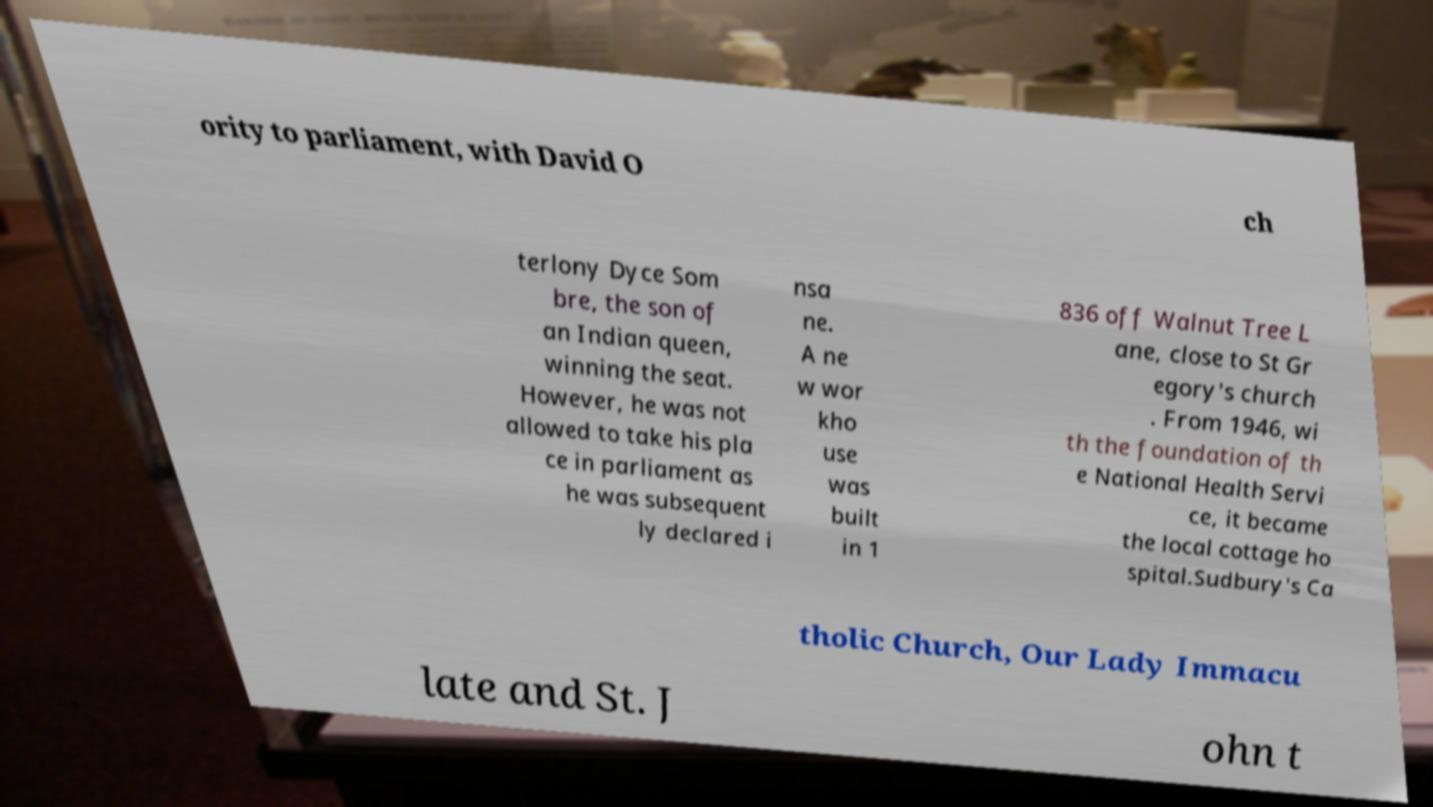Could you assist in decoding the text presented in this image and type it out clearly? ority to parliament, with David O ch terlony Dyce Som bre, the son of an Indian queen, winning the seat. However, he was not allowed to take his pla ce in parliament as he was subsequent ly declared i nsa ne. A ne w wor kho use was built in 1 836 off Walnut Tree L ane, close to St Gr egory's church . From 1946, wi th the foundation of th e National Health Servi ce, it became the local cottage ho spital.Sudbury's Ca tholic Church, Our Lady Immacu late and St. J ohn t 